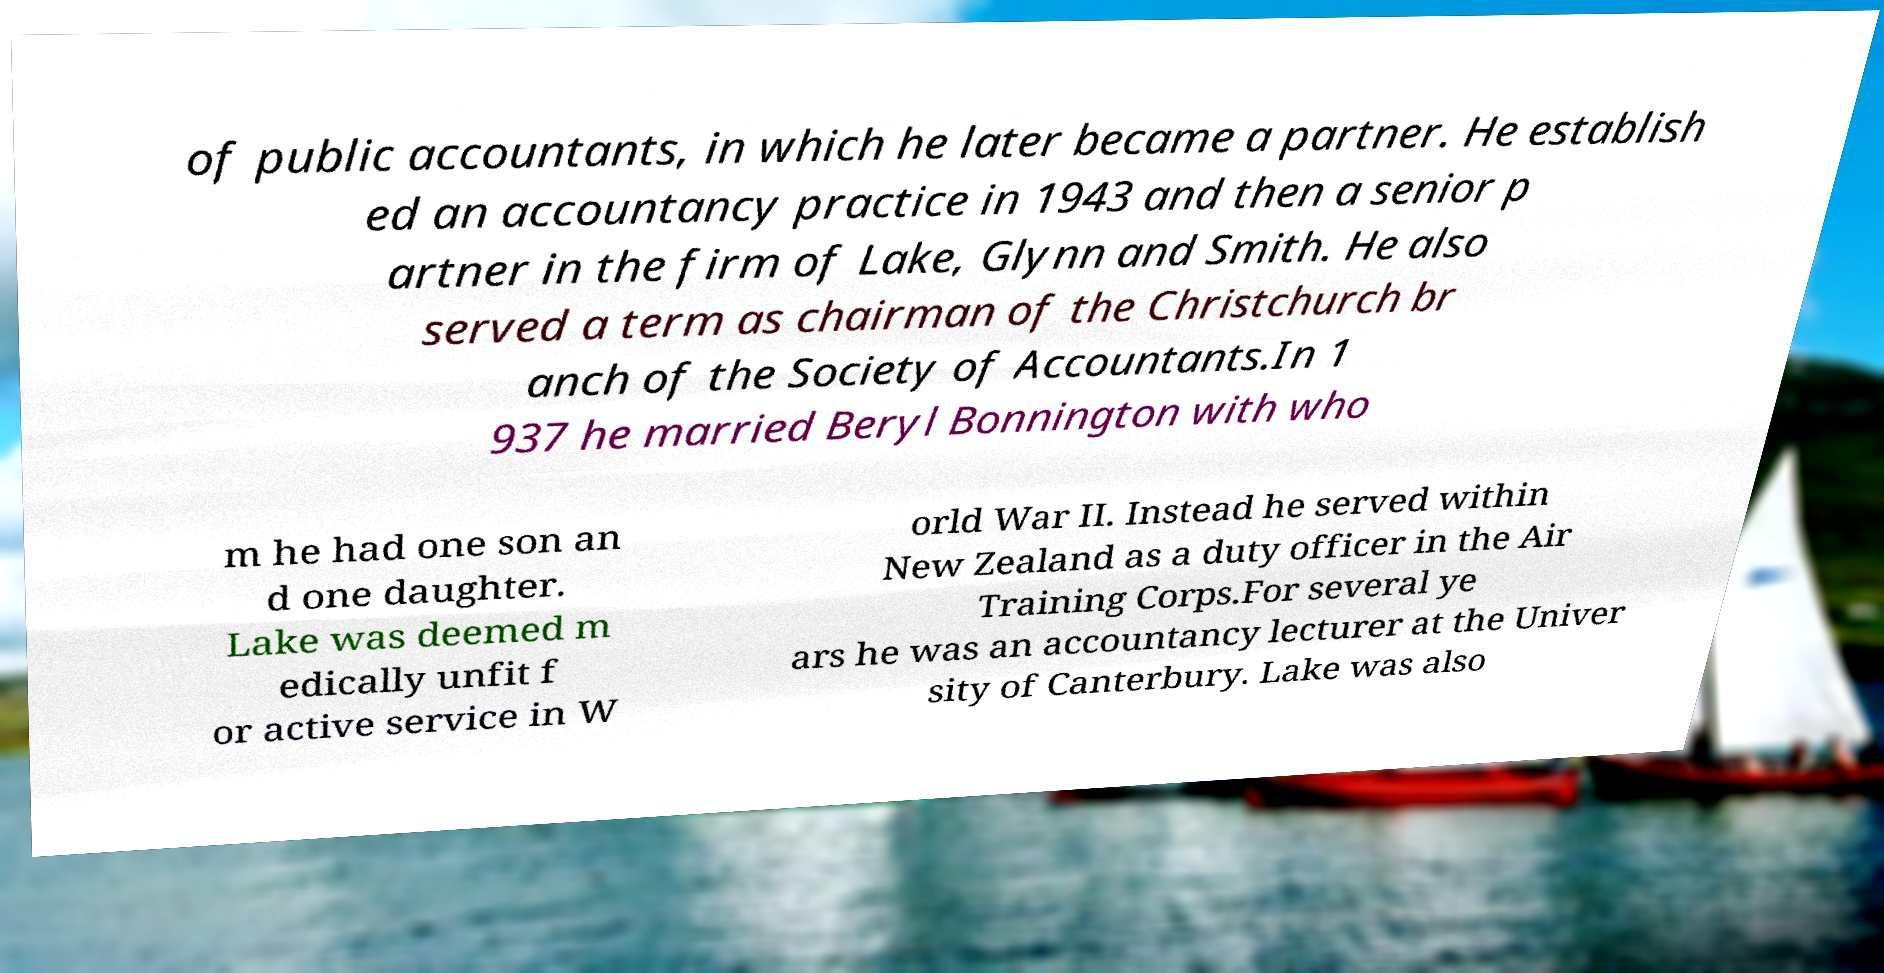There's text embedded in this image that I need extracted. Can you transcribe it verbatim? of public accountants, in which he later became a partner. He establish ed an accountancy practice in 1943 and then a senior p artner in the firm of Lake, Glynn and Smith. He also served a term as chairman of the Christchurch br anch of the Society of Accountants.In 1 937 he married Beryl Bonnington with who m he had one son an d one daughter. Lake was deemed m edically unfit f or active service in W orld War II. Instead he served within New Zealand as a duty officer in the Air Training Corps.For several ye ars he was an accountancy lecturer at the Univer sity of Canterbury. Lake was also 